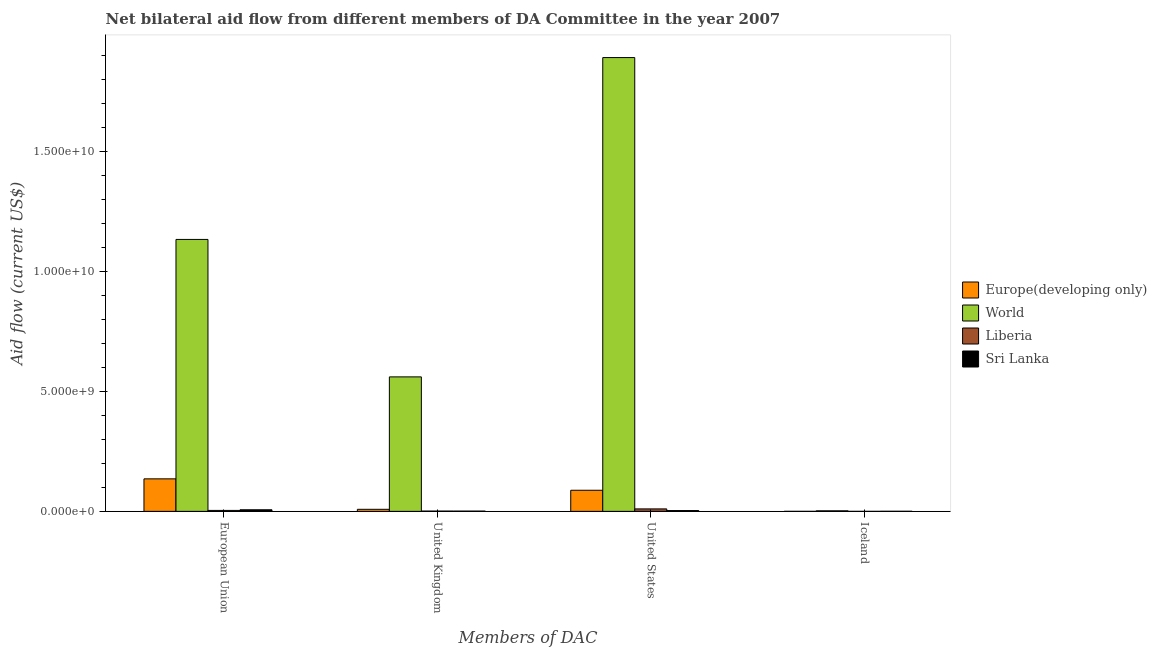How many bars are there on the 3rd tick from the left?
Ensure brevity in your answer.  4. What is the amount of aid given by us in Europe(developing only)?
Offer a very short reply. 8.79e+08. Across all countries, what is the maximum amount of aid given by uk?
Keep it short and to the point. 5.60e+09. Across all countries, what is the minimum amount of aid given by iceland?
Offer a terse response. 1.00e+05. In which country was the amount of aid given by us maximum?
Your response must be concise. World. In which country was the amount of aid given by iceland minimum?
Provide a short and direct response. Liberia. What is the total amount of aid given by us in the graph?
Offer a terse response. 1.99e+1. What is the difference between the amount of aid given by iceland in World and that in Liberia?
Keep it short and to the point. 2.29e+07. What is the difference between the amount of aid given by eu in Europe(developing only) and the amount of aid given by iceland in Liberia?
Make the answer very short. 1.35e+09. What is the average amount of aid given by iceland per country?
Your response must be concise. 6.90e+06. What is the difference between the amount of aid given by uk and amount of aid given by eu in Sri Lanka?
Give a very brief answer. -5.46e+07. In how many countries, is the amount of aid given by iceland greater than 15000000000 US$?
Your answer should be very brief. 0. What is the ratio of the amount of aid given by us in World to that in Europe(developing only)?
Offer a very short reply. 21.5. Is the amount of aid given by us in Liberia less than that in Sri Lanka?
Give a very brief answer. No. Is the difference between the amount of aid given by us in Sri Lanka and Liberia greater than the difference between the amount of aid given by uk in Sri Lanka and Liberia?
Make the answer very short. No. What is the difference between the highest and the second highest amount of aid given by us?
Your answer should be very brief. 1.80e+1. What is the difference between the highest and the lowest amount of aid given by uk?
Provide a short and direct response. 5.59e+09. In how many countries, is the amount of aid given by eu greater than the average amount of aid given by eu taken over all countries?
Give a very brief answer. 1. Is the sum of the amount of aid given by iceland in Europe(developing only) and Liberia greater than the maximum amount of aid given by eu across all countries?
Keep it short and to the point. No. Is it the case that in every country, the sum of the amount of aid given by uk and amount of aid given by iceland is greater than the sum of amount of aid given by us and amount of aid given by eu?
Your response must be concise. No. What does the 1st bar from the left in United Kingdom represents?
Your response must be concise. Europe(developing only). What does the 2nd bar from the right in United Kingdom represents?
Make the answer very short. Liberia. How many bars are there?
Ensure brevity in your answer.  16. Are all the bars in the graph horizontal?
Ensure brevity in your answer.  No. How many countries are there in the graph?
Keep it short and to the point. 4. What is the difference between two consecutive major ticks on the Y-axis?
Provide a succinct answer. 5.00e+09. How are the legend labels stacked?
Offer a terse response. Vertical. What is the title of the graph?
Provide a short and direct response. Net bilateral aid flow from different members of DA Committee in the year 2007. Does "Portugal" appear as one of the legend labels in the graph?
Keep it short and to the point. No. What is the label or title of the X-axis?
Provide a short and direct response. Members of DAC. What is the Aid flow (current US$) in Europe(developing only) in European Union?
Provide a short and direct response. 1.35e+09. What is the Aid flow (current US$) in World in European Union?
Your answer should be compact. 1.13e+1. What is the Aid flow (current US$) of Liberia in European Union?
Your answer should be very brief. 3.95e+07. What is the Aid flow (current US$) of Sri Lanka in European Union?
Provide a short and direct response. 6.61e+07. What is the Aid flow (current US$) in Europe(developing only) in United Kingdom?
Give a very brief answer. 8.58e+07. What is the Aid flow (current US$) of World in United Kingdom?
Your answer should be very brief. 5.60e+09. What is the Aid flow (current US$) in Liberia in United Kingdom?
Give a very brief answer. 1.24e+07. What is the Aid flow (current US$) of Sri Lanka in United Kingdom?
Offer a terse response. 1.15e+07. What is the Aid flow (current US$) of Europe(developing only) in United States?
Your answer should be compact. 8.79e+08. What is the Aid flow (current US$) of World in United States?
Provide a succinct answer. 1.89e+1. What is the Aid flow (current US$) of Liberia in United States?
Provide a succinct answer. 1.03e+08. What is the Aid flow (current US$) in Sri Lanka in United States?
Your response must be concise. 3.35e+07. What is the Aid flow (current US$) of World in Iceland?
Your response must be concise. 2.30e+07. What is the Aid flow (current US$) of Liberia in Iceland?
Keep it short and to the point. 1.00e+05. What is the Aid flow (current US$) in Sri Lanka in Iceland?
Provide a short and direct response. 3.82e+06. Across all Members of DAC, what is the maximum Aid flow (current US$) of Europe(developing only)?
Give a very brief answer. 1.35e+09. Across all Members of DAC, what is the maximum Aid flow (current US$) of World?
Provide a short and direct response. 1.89e+1. Across all Members of DAC, what is the maximum Aid flow (current US$) in Liberia?
Offer a very short reply. 1.03e+08. Across all Members of DAC, what is the maximum Aid flow (current US$) in Sri Lanka?
Offer a terse response. 6.61e+07. Across all Members of DAC, what is the minimum Aid flow (current US$) in World?
Make the answer very short. 2.30e+07. Across all Members of DAC, what is the minimum Aid flow (current US$) in Liberia?
Your answer should be compact. 1.00e+05. Across all Members of DAC, what is the minimum Aid flow (current US$) in Sri Lanka?
Provide a short and direct response. 3.82e+06. What is the total Aid flow (current US$) in Europe(developing only) in the graph?
Your answer should be compact. 2.32e+09. What is the total Aid flow (current US$) of World in the graph?
Provide a short and direct response. 3.59e+1. What is the total Aid flow (current US$) of Liberia in the graph?
Provide a short and direct response. 1.55e+08. What is the total Aid flow (current US$) in Sri Lanka in the graph?
Give a very brief answer. 1.15e+08. What is the difference between the Aid flow (current US$) in Europe(developing only) in European Union and that in United Kingdom?
Provide a succinct answer. 1.27e+09. What is the difference between the Aid flow (current US$) of World in European Union and that in United Kingdom?
Provide a succinct answer. 5.72e+09. What is the difference between the Aid flow (current US$) of Liberia in European Union and that in United Kingdom?
Make the answer very short. 2.71e+07. What is the difference between the Aid flow (current US$) in Sri Lanka in European Union and that in United Kingdom?
Make the answer very short. 5.46e+07. What is the difference between the Aid flow (current US$) in Europe(developing only) in European Union and that in United States?
Keep it short and to the point. 4.75e+08. What is the difference between the Aid flow (current US$) in World in European Union and that in United States?
Your answer should be very brief. -7.58e+09. What is the difference between the Aid flow (current US$) of Liberia in European Union and that in United States?
Provide a succinct answer. -6.33e+07. What is the difference between the Aid flow (current US$) in Sri Lanka in European Union and that in United States?
Provide a succinct answer. 3.27e+07. What is the difference between the Aid flow (current US$) of Europe(developing only) in European Union and that in Iceland?
Ensure brevity in your answer.  1.35e+09. What is the difference between the Aid flow (current US$) in World in European Union and that in Iceland?
Provide a succinct answer. 1.13e+1. What is the difference between the Aid flow (current US$) in Liberia in European Union and that in Iceland?
Provide a succinct answer. 3.94e+07. What is the difference between the Aid flow (current US$) in Sri Lanka in European Union and that in Iceland?
Keep it short and to the point. 6.23e+07. What is the difference between the Aid flow (current US$) in Europe(developing only) in United Kingdom and that in United States?
Offer a very short reply. -7.93e+08. What is the difference between the Aid flow (current US$) in World in United Kingdom and that in United States?
Give a very brief answer. -1.33e+1. What is the difference between the Aid flow (current US$) in Liberia in United Kingdom and that in United States?
Offer a very short reply. -9.04e+07. What is the difference between the Aid flow (current US$) of Sri Lanka in United Kingdom and that in United States?
Provide a short and direct response. -2.20e+07. What is the difference between the Aid flow (current US$) of Europe(developing only) in United Kingdom and that in Iceland?
Offer a very short reply. 8.51e+07. What is the difference between the Aid flow (current US$) of World in United Kingdom and that in Iceland?
Provide a succinct answer. 5.58e+09. What is the difference between the Aid flow (current US$) of Liberia in United Kingdom and that in Iceland?
Offer a terse response. 1.23e+07. What is the difference between the Aid flow (current US$) of Sri Lanka in United Kingdom and that in Iceland?
Provide a short and direct response. 7.68e+06. What is the difference between the Aid flow (current US$) of Europe(developing only) in United States and that in Iceland?
Your answer should be very brief. 8.78e+08. What is the difference between the Aid flow (current US$) of World in United States and that in Iceland?
Offer a very short reply. 1.89e+1. What is the difference between the Aid flow (current US$) in Liberia in United States and that in Iceland?
Your answer should be very brief. 1.03e+08. What is the difference between the Aid flow (current US$) of Sri Lanka in United States and that in Iceland?
Make the answer very short. 2.97e+07. What is the difference between the Aid flow (current US$) in Europe(developing only) in European Union and the Aid flow (current US$) in World in United Kingdom?
Provide a short and direct response. -4.25e+09. What is the difference between the Aid flow (current US$) in Europe(developing only) in European Union and the Aid flow (current US$) in Liberia in United Kingdom?
Offer a very short reply. 1.34e+09. What is the difference between the Aid flow (current US$) in Europe(developing only) in European Union and the Aid flow (current US$) in Sri Lanka in United Kingdom?
Provide a succinct answer. 1.34e+09. What is the difference between the Aid flow (current US$) of World in European Union and the Aid flow (current US$) of Liberia in United Kingdom?
Give a very brief answer. 1.13e+1. What is the difference between the Aid flow (current US$) of World in European Union and the Aid flow (current US$) of Sri Lanka in United Kingdom?
Make the answer very short. 1.13e+1. What is the difference between the Aid flow (current US$) in Liberia in European Union and the Aid flow (current US$) in Sri Lanka in United Kingdom?
Ensure brevity in your answer.  2.80e+07. What is the difference between the Aid flow (current US$) in Europe(developing only) in European Union and the Aid flow (current US$) in World in United States?
Ensure brevity in your answer.  -1.75e+1. What is the difference between the Aid flow (current US$) of Europe(developing only) in European Union and the Aid flow (current US$) of Liberia in United States?
Offer a very short reply. 1.25e+09. What is the difference between the Aid flow (current US$) in Europe(developing only) in European Union and the Aid flow (current US$) in Sri Lanka in United States?
Give a very brief answer. 1.32e+09. What is the difference between the Aid flow (current US$) of World in European Union and the Aid flow (current US$) of Liberia in United States?
Offer a terse response. 1.12e+1. What is the difference between the Aid flow (current US$) of World in European Union and the Aid flow (current US$) of Sri Lanka in United States?
Offer a terse response. 1.13e+1. What is the difference between the Aid flow (current US$) of Liberia in European Union and the Aid flow (current US$) of Sri Lanka in United States?
Offer a terse response. 5.98e+06. What is the difference between the Aid flow (current US$) of Europe(developing only) in European Union and the Aid flow (current US$) of World in Iceland?
Your answer should be compact. 1.33e+09. What is the difference between the Aid flow (current US$) in Europe(developing only) in European Union and the Aid flow (current US$) in Liberia in Iceland?
Your response must be concise. 1.35e+09. What is the difference between the Aid flow (current US$) of Europe(developing only) in European Union and the Aid flow (current US$) of Sri Lanka in Iceland?
Offer a very short reply. 1.35e+09. What is the difference between the Aid flow (current US$) in World in European Union and the Aid flow (current US$) in Liberia in Iceland?
Offer a very short reply. 1.13e+1. What is the difference between the Aid flow (current US$) in World in European Union and the Aid flow (current US$) in Sri Lanka in Iceland?
Give a very brief answer. 1.13e+1. What is the difference between the Aid flow (current US$) of Liberia in European Union and the Aid flow (current US$) of Sri Lanka in Iceland?
Give a very brief answer. 3.56e+07. What is the difference between the Aid flow (current US$) of Europe(developing only) in United Kingdom and the Aid flow (current US$) of World in United States?
Your answer should be very brief. -1.88e+1. What is the difference between the Aid flow (current US$) in Europe(developing only) in United Kingdom and the Aid flow (current US$) in Liberia in United States?
Give a very brief answer. -1.70e+07. What is the difference between the Aid flow (current US$) in Europe(developing only) in United Kingdom and the Aid flow (current US$) in Sri Lanka in United States?
Your answer should be very brief. 5.23e+07. What is the difference between the Aid flow (current US$) of World in United Kingdom and the Aid flow (current US$) of Liberia in United States?
Your response must be concise. 5.50e+09. What is the difference between the Aid flow (current US$) in World in United Kingdom and the Aid flow (current US$) in Sri Lanka in United States?
Your answer should be very brief. 5.57e+09. What is the difference between the Aid flow (current US$) in Liberia in United Kingdom and the Aid flow (current US$) in Sri Lanka in United States?
Make the answer very short. -2.11e+07. What is the difference between the Aid flow (current US$) in Europe(developing only) in United Kingdom and the Aid flow (current US$) in World in Iceland?
Ensure brevity in your answer.  6.27e+07. What is the difference between the Aid flow (current US$) in Europe(developing only) in United Kingdom and the Aid flow (current US$) in Liberia in Iceland?
Your response must be concise. 8.56e+07. What is the difference between the Aid flow (current US$) of Europe(developing only) in United Kingdom and the Aid flow (current US$) of Sri Lanka in Iceland?
Your response must be concise. 8.19e+07. What is the difference between the Aid flow (current US$) of World in United Kingdom and the Aid flow (current US$) of Liberia in Iceland?
Ensure brevity in your answer.  5.60e+09. What is the difference between the Aid flow (current US$) in World in United Kingdom and the Aid flow (current US$) in Sri Lanka in Iceland?
Your answer should be very brief. 5.60e+09. What is the difference between the Aid flow (current US$) of Liberia in United Kingdom and the Aid flow (current US$) of Sri Lanka in Iceland?
Your response must be concise. 8.54e+06. What is the difference between the Aid flow (current US$) of Europe(developing only) in United States and the Aid flow (current US$) of World in Iceland?
Your response must be concise. 8.56e+08. What is the difference between the Aid flow (current US$) of Europe(developing only) in United States and the Aid flow (current US$) of Liberia in Iceland?
Give a very brief answer. 8.79e+08. What is the difference between the Aid flow (current US$) in Europe(developing only) in United States and the Aid flow (current US$) in Sri Lanka in Iceland?
Your answer should be compact. 8.75e+08. What is the difference between the Aid flow (current US$) of World in United States and the Aid flow (current US$) of Liberia in Iceland?
Offer a very short reply. 1.89e+1. What is the difference between the Aid flow (current US$) of World in United States and the Aid flow (current US$) of Sri Lanka in Iceland?
Ensure brevity in your answer.  1.89e+1. What is the difference between the Aid flow (current US$) of Liberia in United States and the Aid flow (current US$) of Sri Lanka in Iceland?
Your answer should be compact. 9.89e+07. What is the average Aid flow (current US$) in Europe(developing only) per Members of DAC?
Make the answer very short. 5.80e+08. What is the average Aid flow (current US$) of World per Members of DAC?
Provide a succinct answer. 8.96e+09. What is the average Aid flow (current US$) of Liberia per Members of DAC?
Keep it short and to the point. 3.87e+07. What is the average Aid flow (current US$) of Sri Lanka per Members of DAC?
Your answer should be very brief. 2.87e+07. What is the difference between the Aid flow (current US$) in Europe(developing only) and Aid flow (current US$) in World in European Union?
Your answer should be very brief. -9.97e+09. What is the difference between the Aid flow (current US$) of Europe(developing only) and Aid flow (current US$) of Liberia in European Union?
Ensure brevity in your answer.  1.31e+09. What is the difference between the Aid flow (current US$) in Europe(developing only) and Aid flow (current US$) in Sri Lanka in European Union?
Offer a terse response. 1.29e+09. What is the difference between the Aid flow (current US$) of World and Aid flow (current US$) of Liberia in European Union?
Your response must be concise. 1.13e+1. What is the difference between the Aid flow (current US$) in World and Aid flow (current US$) in Sri Lanka in European Union?
Provide a short and direct response. 1.13e+1. What is the difference between the Aid flow (current US$) of Liberia and Aid flow (current US$) of Sri Lanka in European Union?
Ensure brevity in your answer.  -2.67e+07. What is the difference between the Aid flow (current US$) in Europe(developing only) and Aid flow (current US$) in World in United Kingdom?
Offer a very short reply. -5.52e+09. What is the difference between the Aid flow (current US$) in Europe(developing only) and Aid flow (current US$) in Liberia in United Kingdom?
Keep it short and to the point. 7.34e+07. What is the difference between the Aid flow (current US$) of Europe(developing only) and Aid flow (current US$) of Sri Lanka in United Kingdom?
Provide a succinct answer. 7.42e+07. What is the difference between the Aid flow (current US$) of World and Aid flow (current US$) of Liberia in United Kingdom?
Your answer should be compact. 5.59e+09. What is the difference between the Aid flow (current US$) in World and Aid flow (current US$) in Sri Lanka in United Kingdom?
Your answer should be compact. 5.59e+09. What is the difference between the Aid flow (current US$) in Liberia and Aid flow (current US$) in Sri Lanka in United Kingdom?
Provide a short and direct response. 8.60e+05. What is the difference between the Aid flow (current US$) of Europe(developing only) and Aid flow (current US$) of World in United States?
Your answer should be compact. -1.80e+1. What is the difference between the Aid flow (current US$) of Europe(developing only) and Aid flow (current US$) of Liberia in United States?
Keep it short and to the point. 7.76e+08. What is the difference between the Aid flow (current US$) of Europe(developing only) and Aid flow (current US$) of Sri Lanka in United States?
Offer a very short reply. 8.46e+08. What is the difference between the Aid flow (current US$) of World and Aid flow (current US$) of Liberia in United States?
Provide a succinct answer. 1.88e+1. What is the difference between the Aid flow (current US$) of World and Aid flow (current US$) of Sri Lanka in United States?
Provide a succinct answer. 1.89e+1. What is the difference between the Aid flow (current US$) of Liberia and Aid flow (current US$) of Sri Lanka in United States?
Your answer should be very brief. 6.92e+07. What is the difference between the Aid flow (current US$) of Europe(developing only) and Aid flow (current US$) of World in Iceland?
Provide a succinct answer. -2.24e+07. What is the difference between the Aid flow (current US$) in Europe(developing only) and Aid flow (current US$) in Liberia in Iceland?
Give a very brief answer. 5.60e+05. What is the difference between the Aid flow (current US$) of Europe(developing only) and Aid flow (current US$) of Sri Lanka in Iceland?
Ensure brevity in your answer.  -3.16e+06. What is the difference between the Aid flow (current US$) in World and Aid flow (current US$) in Liberia in Iceland?
Your answer should be compact. 2.29e+07. What is the difference between the Aid flow (current US$) of World and Aid flow (current US$) of Sri Lanka in Iceland?
Give a very brief answer. 1.92e+07. What is the difference between the Aid flow (current US$) in Liberia and Aid flow (current US$) in Sri Lanka in Iceland?
Give a very brief answer. -3.72e+06. What is the ratio of the Aid flow (current US$) in Europe(developing only) in European Union to that in United Kingdom?
Offer a terse response. 15.79. What is the ratio of the Aid flow (current US$) of World in European Union to that in United Kingdom?
Ensure brevity in your answer.  2.02. What is the ratio of the Aid flow (current US$) of Liberia in European Union to that in United Kingdom?
Your response must be concise. 3.19. What is the ratio of the Aid flow (current US$) in Sri Lanka in European Union to that in United Kingdom?
Offer a very short reply. 5.75. What is the ratio of the Aid flow (current US$) in Europe(developing only) in European Union to that in United States?
Keep it short and to the point. 1.54. What is the ratio of the Aid flow (current US$) in World in European Union to that in United States?
Provide a short and direct response. 0.6. What is the ratio of the Aid flow (current US$) of Liberia in European Union to that in United States?
Offer a very short reply. 0.38. What is the ratio of the Aid flow (current US$) in Sri Lanka in European Union to that in United States?
Provide a succinct answer. 1.98. What is the ratio of the Aid flow (current US$) in Europe(developing only) in European Union to that in Iceland?
Provide a succinct answer. 2051.32. What is the ratio of the Aid flow (current US$) in World in European Union to that in Iceland?
Make the answer very short. 492.23. What is the ratio of the Aid flow (current US$) in Liberia in European Union to that in Iceland?
Your answer should be compact. 394.6. What is the ratio of the Aid flow (current US$) in Sri Lanka in European Union to that in Iceland?
Provide a succinct answer. 17.31. What is the ratio of the Aid flow (current US$) of Europe(developing only) in United Kingdom to that in United States?
Make the answer very short. 0.1. What is the ratio of the Aid flow (current US$) in World in United Kingdom to that in United States?
Ensure brevity in your answer.  0.3. What is the ratio of the Aid flow (current US$) of Liberia in United Kingdom to that in United States?
Make the answer very short. 0.12. What is the ratio of the Aid flow (current US$) of Sri Lanka in United Kingdom to that in United States?
Provide a short and direct response. 0.34. What is the ratio of the Aid flow (current US$) in Europe(developing only) in United Kingdom to that in Iceland?
Offer a terse response. 129.92. What is the ratio of the Aid flow (current US$) of World in United Kingdom to that in Iceland?
Make the answer very short. 243.44. What is the ratio of the Aid flow (current US$) of Liberia in United Kingdom to that in Iceland?
Ensure brevity in your answer.  123.6. What is the ratio of the Aid flow (current US$) of Sri Lanka in United Kingdom to that in Iceland?
Provide a short and direct response. 3.01. What is the ratio of the Aid flow (current US$) in Europe(developing only) in United States to that in Iceland?
Give a very brief answer. 1332.03. What is the ratio of the Aid flow (current US$) in World in United States to that in Iceland?
Your answer should be very brief. 821.43. What is the ratio of the Aid flow (current US$) of Liberia in United States to that in Iceland?
Offer a terse response. 1027.3. What is the ratio of the Aid flow (current US$) in Sri Lanka in United States to that in Iceland?
Give a very brief answer. 8.76. What is the difference between the highest and the second highest Aid flow (current US$) in Europe(developing only)?
Offer a terse response. 4.75e+08. What is the difference between the highest and the second highest Aid flow (current US$) of World?
Offer a terse response. 7.58e+09. What is the difference between the highest and the second highest Aid flow (current US$) of Liberia?
Ensure brevity in your answer.  6.33e+07. What is the difference between the highest and the second highest Aid flow (current US$) of Sri Lanka?
Keep it short and to the point. 3.27e+07. What is the difference between the highest and the lowest Aid flow (current US$) of Europe(developing only)?
Keep it short and to the point. 1.35e+09. What is the difference between the highest and the lowest Aid flow (current US$) of World?
Your response must be concise. 1.89e+1. What is the difference between the highest and the lowest Aid flow (current US$) of Liberia?
Keep it short and to the point. 1.03e+08. What is the difference between the highest and the lowest Aid flow (current US$) of Sri Lanka?
Provide a succinct answer. 6.23e+07. 